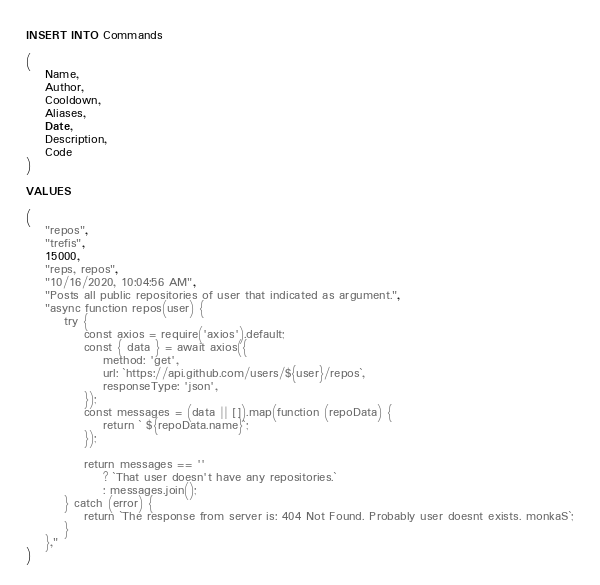Convert code to text. <code><loc_0><loc_0><loc_500><loc_500><_SQL_>INSERT INTO Commands 

(
    Name,
    Author,
    Cooldown,
    Aliases, 
    Date, 
    Description,
    Code
)

VALUES

(
    "repos",
	"trefis",
	15000,
	"reps, repos",
	"10/16/2020, 10:04:56 AM",
    "Posts all public repositories of user that indicated as argument.",
	"async function repos(user) {
		try {
			const axios = require('axios').default;
			const { data } = await axios({
				method: 'get',
				url: `https://api.github.com/users/${user}/repos`,
				responseType: 'json',
			});
			const messages = (data || []).map(function (repoData) {
				return ` ${repoData.name}`;
			});

			return messages == ''
				? `That user doesn't have any repositories.`
				: messages.join();
		} catch (error) {
			return `The response from server is: 404 Not Found. Probably user doesnt exists. monkaS`;
		}
	},"
)


</code> 